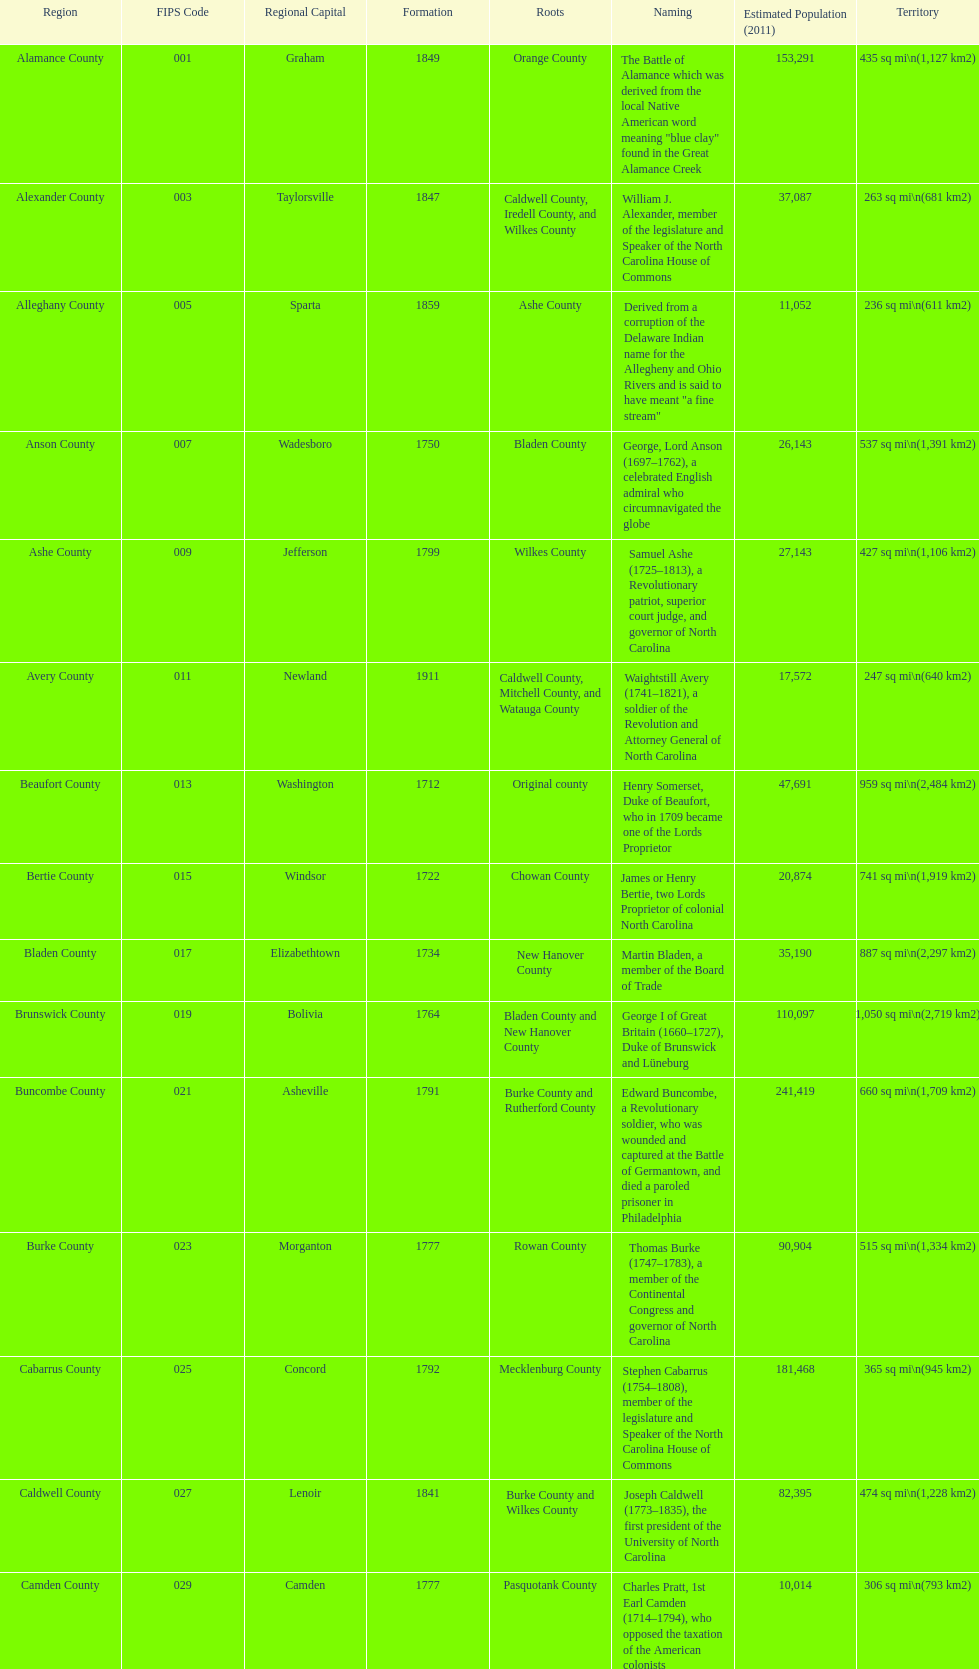What number of counties are named for us presidents? 3. 